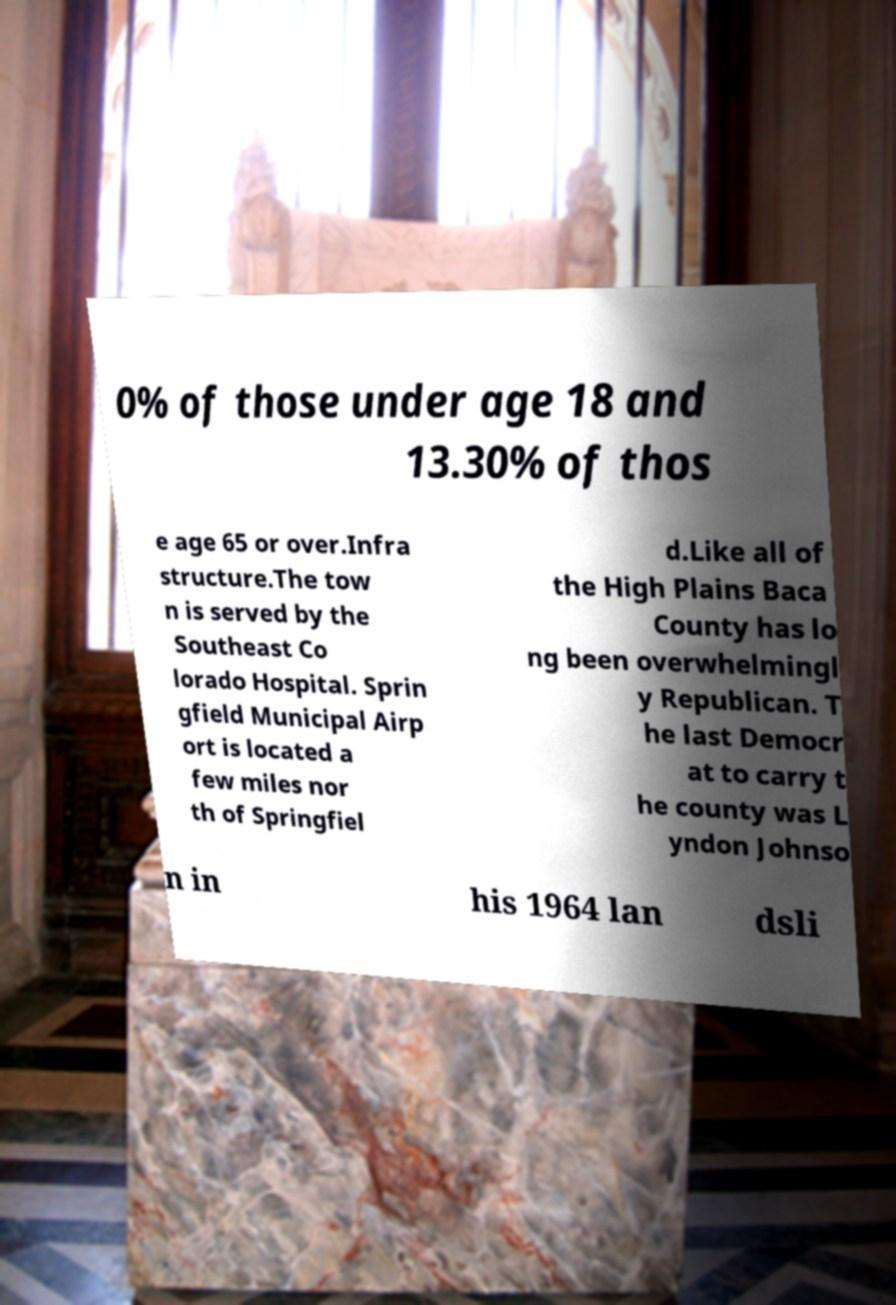Can you read and provide the text displayed in the image?This photo seems to have some interesting text. Can you extract and type it out for me? 0% of those under age 18 and 13.30% of thos e age 65 or over.Infra structure.The tow n is served by the Southeast Co lorado Hospital. Sprin gfield Municipal Airp ort is located a few miles nor th of Springfiel d.Like all of the High Plains Baca County has lo ng been overwhelmingl y Republican. T he last Democr at to carry t he county was L yndon Johnso n in his 1964 lan dsli 